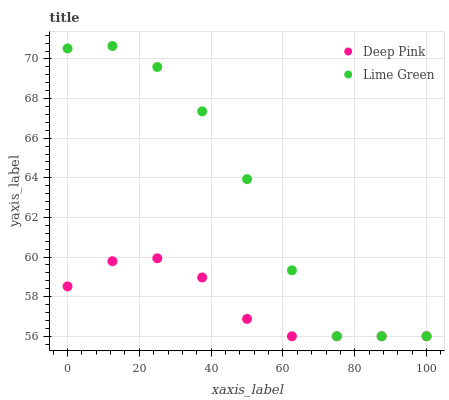Does Deep Pink have the minimum area under the curve?
Answer yes or no. Yes. Does Lime Green have the maximum area under the curve?
Answer yes or no. Yes. Does Lime Green have the minimum area under the curve?
Answer yes or no. No. Is Deep Pink the smoothest?
Answer yes or no. Yes. Is Lime Green the roughest?
Answer yes or no. Yes. Is Lime Green the smoothest?
Answer yes or no. No. Does Deep Pink have the lowest value?
Answer yes or no. Yes. Does Lime Green have the highest value?
Answer yes or no. Yes. Does Lime Green intersect Deep Pink?
Answer yes or no. Yes. Is Lime Green less than Deep Pink?
Answer yes or no. No. Is Lime Green greater than Deep Pink?
Answer yes or no. No. 